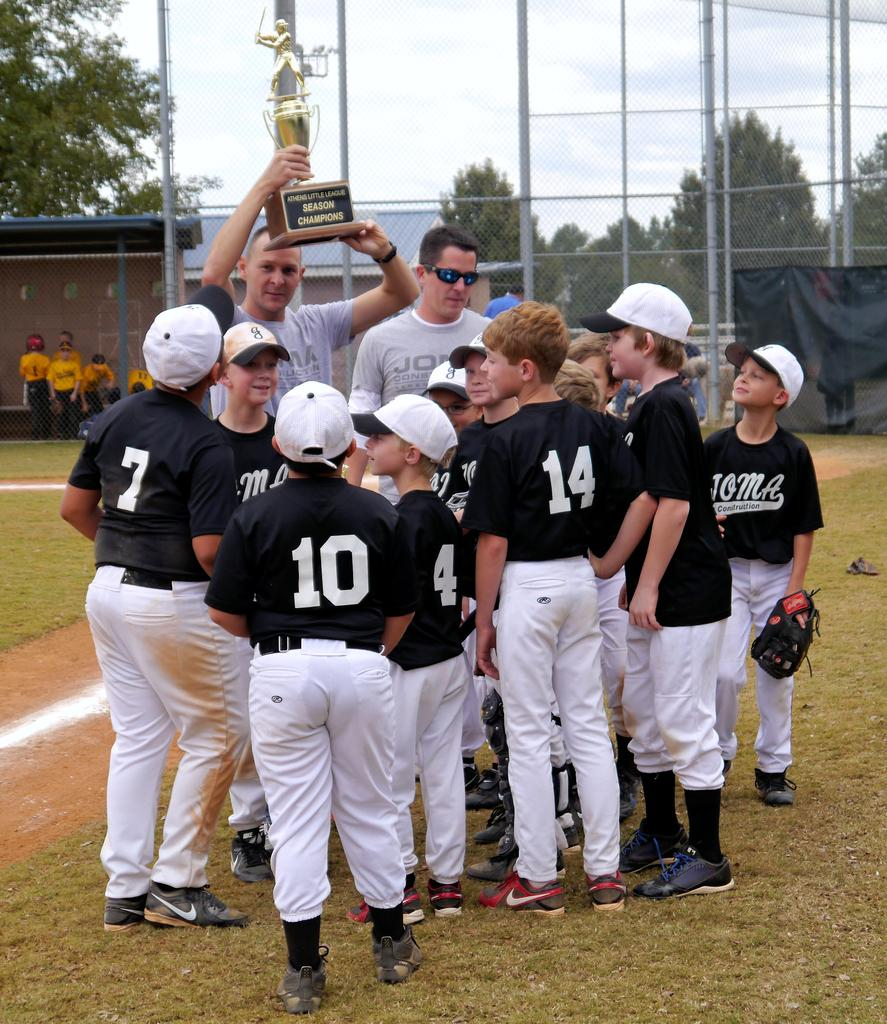<image>
Give a short and clear explanation of the subsequent image. A group of little league baseball players circled up with their coaches hold up a trophy. 